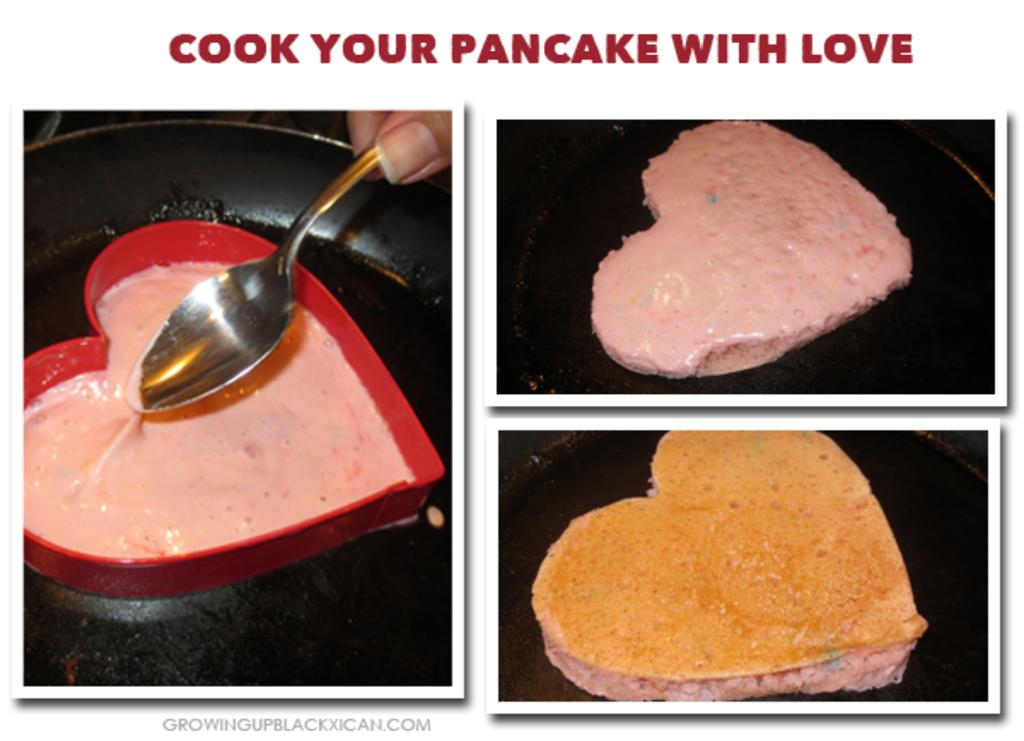What type of food is the main subject of the image? The image contains a collage of pancakes. Can you see a lake or seashore in the background of the image? There is no lake or seashore visible in the image, as it features a collage of pancakes. 